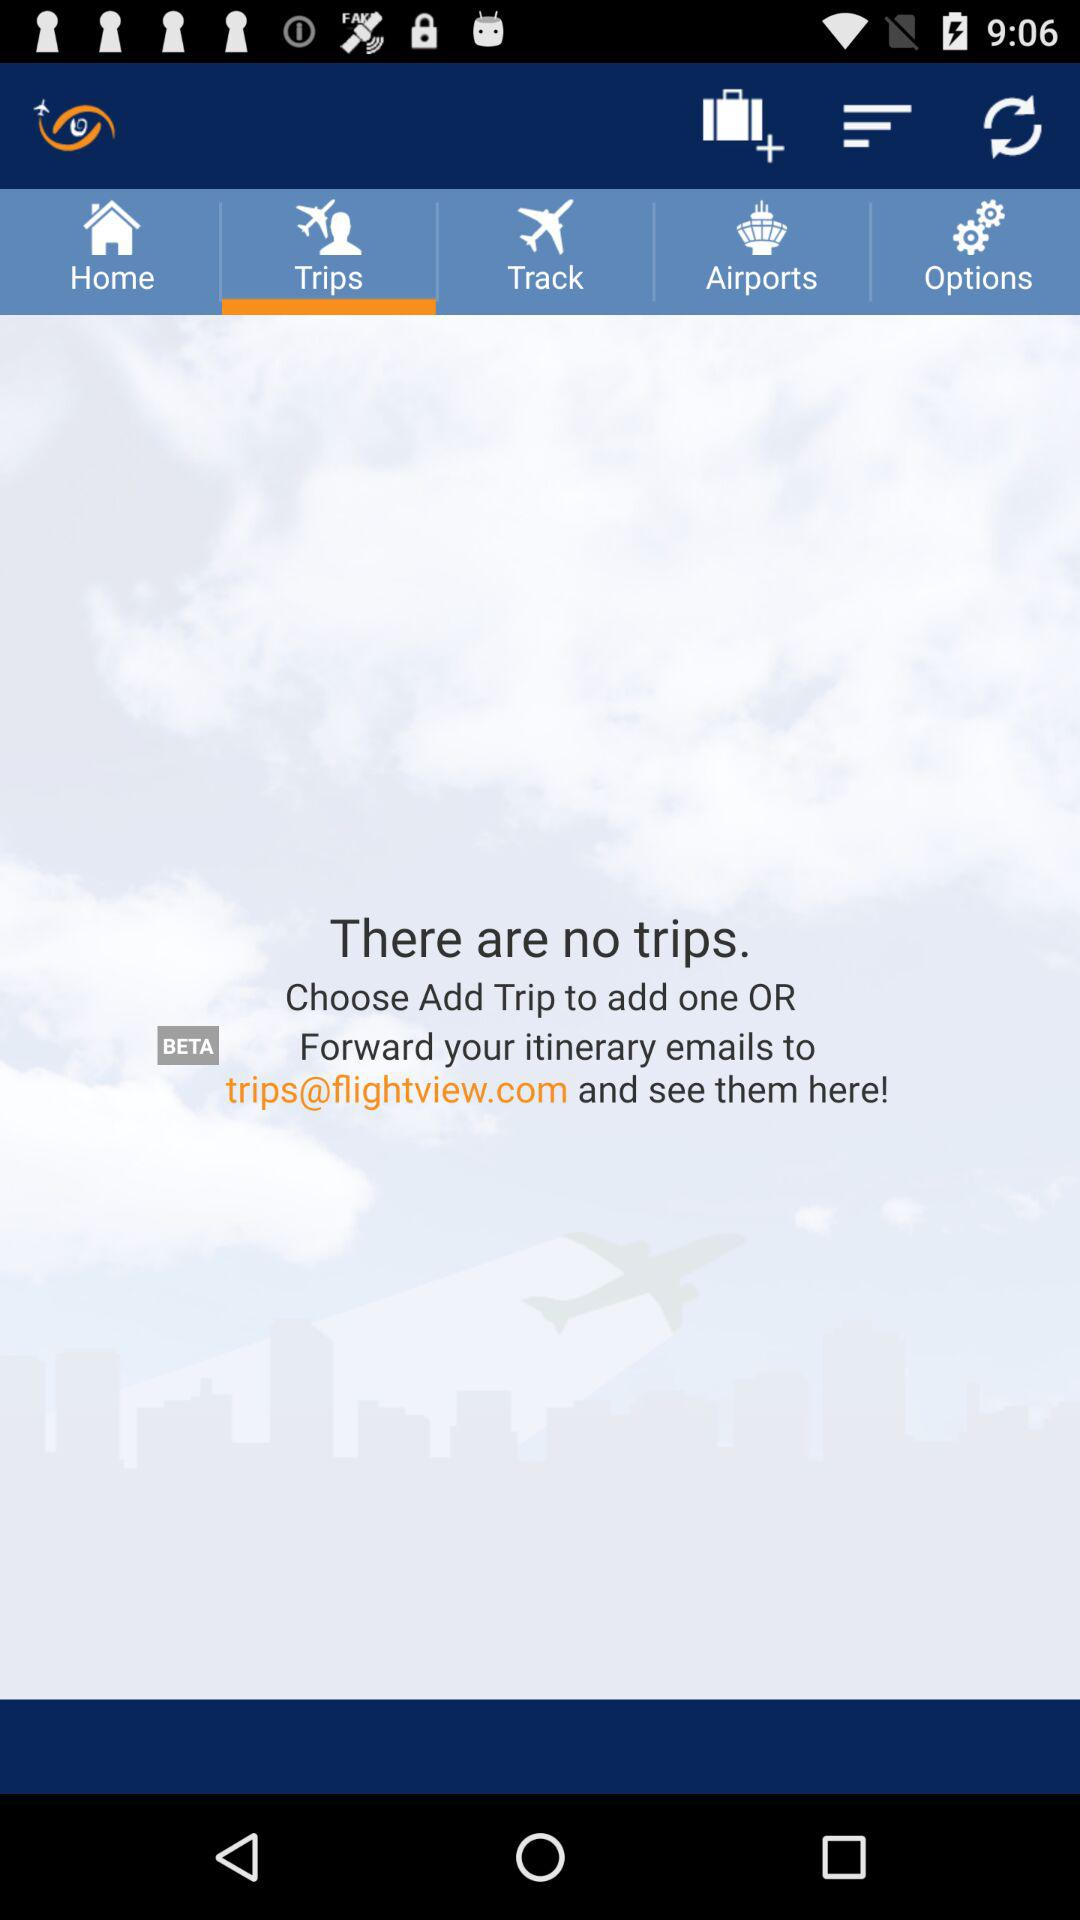How many notifications are there in "Options"?
When the provided information is insufficient, respond with <no answer>. <no answer> 